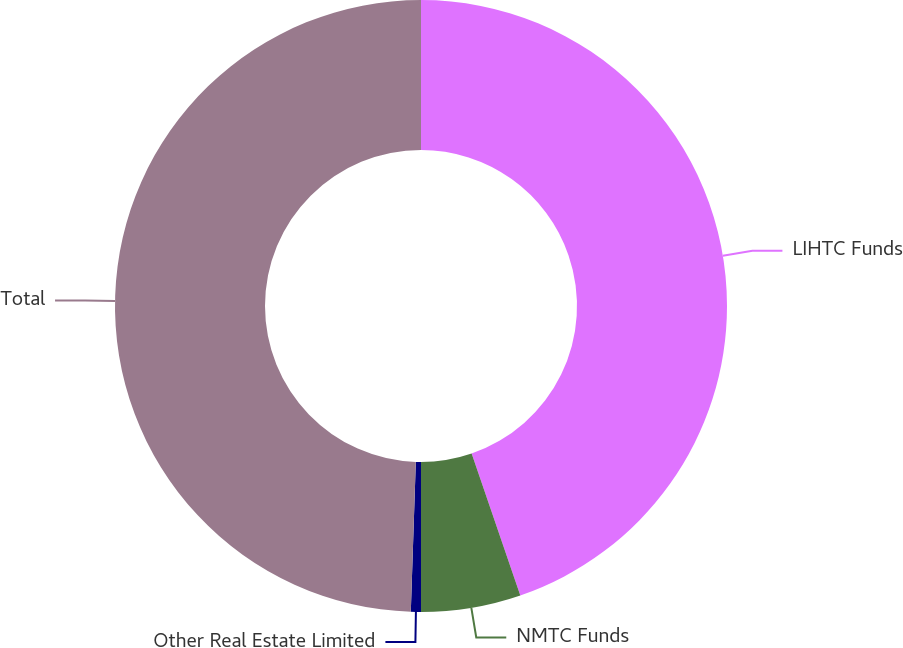Convert chart to OTSL. <chart><loc_0><loc_0><loc_500><loc_500><pie_chart><fcel>LIHTC Funds<fcel>NMTC Funds<fcel>Other Real Estate Limited<fcel>Total<nl><fcel>44.74%<fcel>5.26%<fcel>0.53%<fcel>49.47%<nl></chart> 